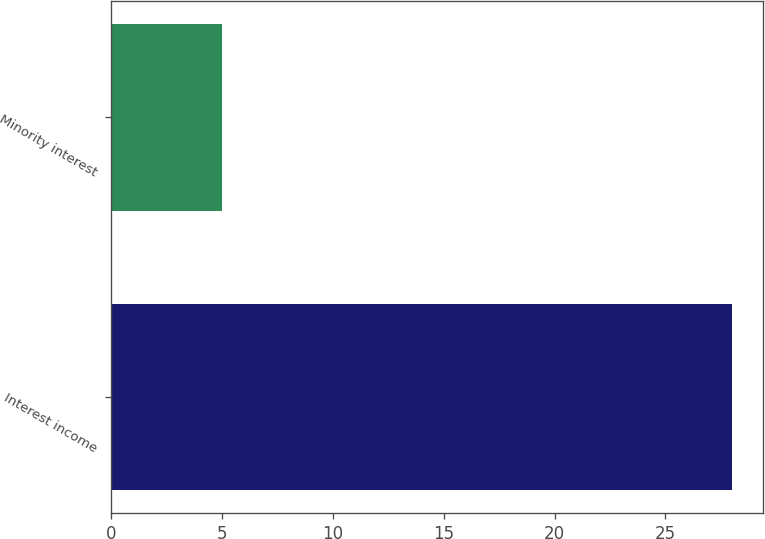Convert chart to OTSL. <chart><loc_0><loc_0><loc_500><loc_500><bar_chart><fcel>Interest income<fcel>Minority interest<nl><fcel>28<fcel>5<nl></chart> 